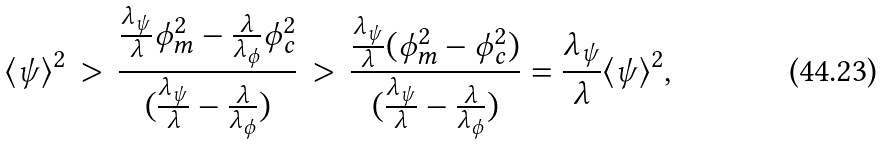Convert formula to latex. <formula><loc_0><loc_0><loc_500><loc_500>\langle \psi \rangle ^ { 2 } \, > \, \frac { \frac { \lambda _ { \psi } } { \lambda } \phi _ { m } ^ { 2 } - \frac { \lambda } { \lambda _ { \phi } } \phi _ { c } ^ { 2 } } { ( \frac { \lambda _ { \psi } } { \lambda } - \frac { \lambda } { \lambda _ { \phi } } ) } \, > \, \frac { \frac { \lambda _ { \psi } } { \lambda } ( \phi _ { m } ^ { 2 } - \phi _ { c } ^ { 2 } ) } { ( \frac { \lambda _ { \psi } } { \lambda } - \frac { \lambda } { \lambda _ { \phi } } ) } = \frac { \lambda _ { \psi } } { \lambda } \langle \psi \rangle ^ { 2 } ,</formula> 